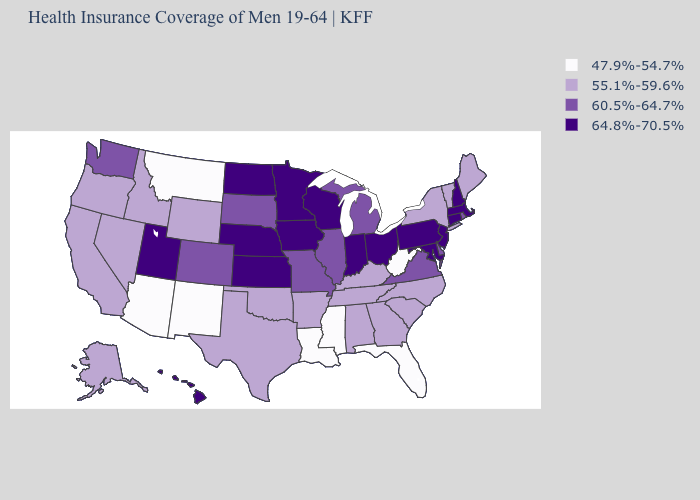What is the highest value in the USA?
Concise answer only. 64.8%-70.5%. Name the states that have a value in the range 60.5%-64.7%?
Give a very brief answer. Colorado, Delaware, Illinois, Michigan, Missouri, Rhode Island, South Dakota, Virginia, Washington. What is the value of Massachusetts?
Answer briefly. 64.8%-70.5%. Name the states that have a value in the range 55.1%-59.6%?
Keep it brief. Alabama, Alaska, Arkansas, California, Georgia, Idaho, Kentucky, Maine, Nevada, New York, North Carolina, Oklahoma, Oregon, South Carolina, Tennessee, Texas, Vermont, Wyoming. Among the states that border Alabama , which have the highest value?
Write a very short answer. Georgia, Tennessee. Does New Mexico have the lowest value in the USA?
Short answer required. Yes. What is the highest value in the MidWest ?
Keep it brief. 64.8%-70.5%. Name the states that have a value in the range 60.5%-64.7%?
Quick response, please. Colorado, Delaware, Illinois, Michigan, Missouri, Rhode Island, South Dakota, Virginia, Washington. Name the states that have a value in the range 47.9%-54.7%?
Keep it brief. Arizona, Florida, Louisiana, Mississippi, Montana, New Mexico, West Virginia. What is the value of Utah?
Keep it brief. 64.8%-70.5%. What is the value of Mississippi?
Concise answer only. 47.9%-54.7%. Which states have the lowest value in the USA?
Short answer required. Arizona, Florida, Louisiana, Mississippi, Montana, New Mexico, West Virginia. Name the states that have a value in the range 55.1%-59.6%?
Keep it brief. Alabama, Alaska, Arkansas, California, Georgia, Idaho, Kentucky, Maine, Nevada, New York, North Carolina, Oklahoma, Oregon, South Carolina, Tennessee, Texas, Vermont, Wyoming. Name the states that have a value in the range 64.8%-70.5%?
Write a very short answer. Connecticut, Hawaii, Indiana, Iowa, Kansas, Maryland, Massachusetts, Minnesota, Nebraska, New Hampshire, New Jersey, North Dakota, Ohio, Pennsylvania, Utah, Wisconsin. Does the first symbol in the legend represent the smallest category?
Concise answer only. Yes. 